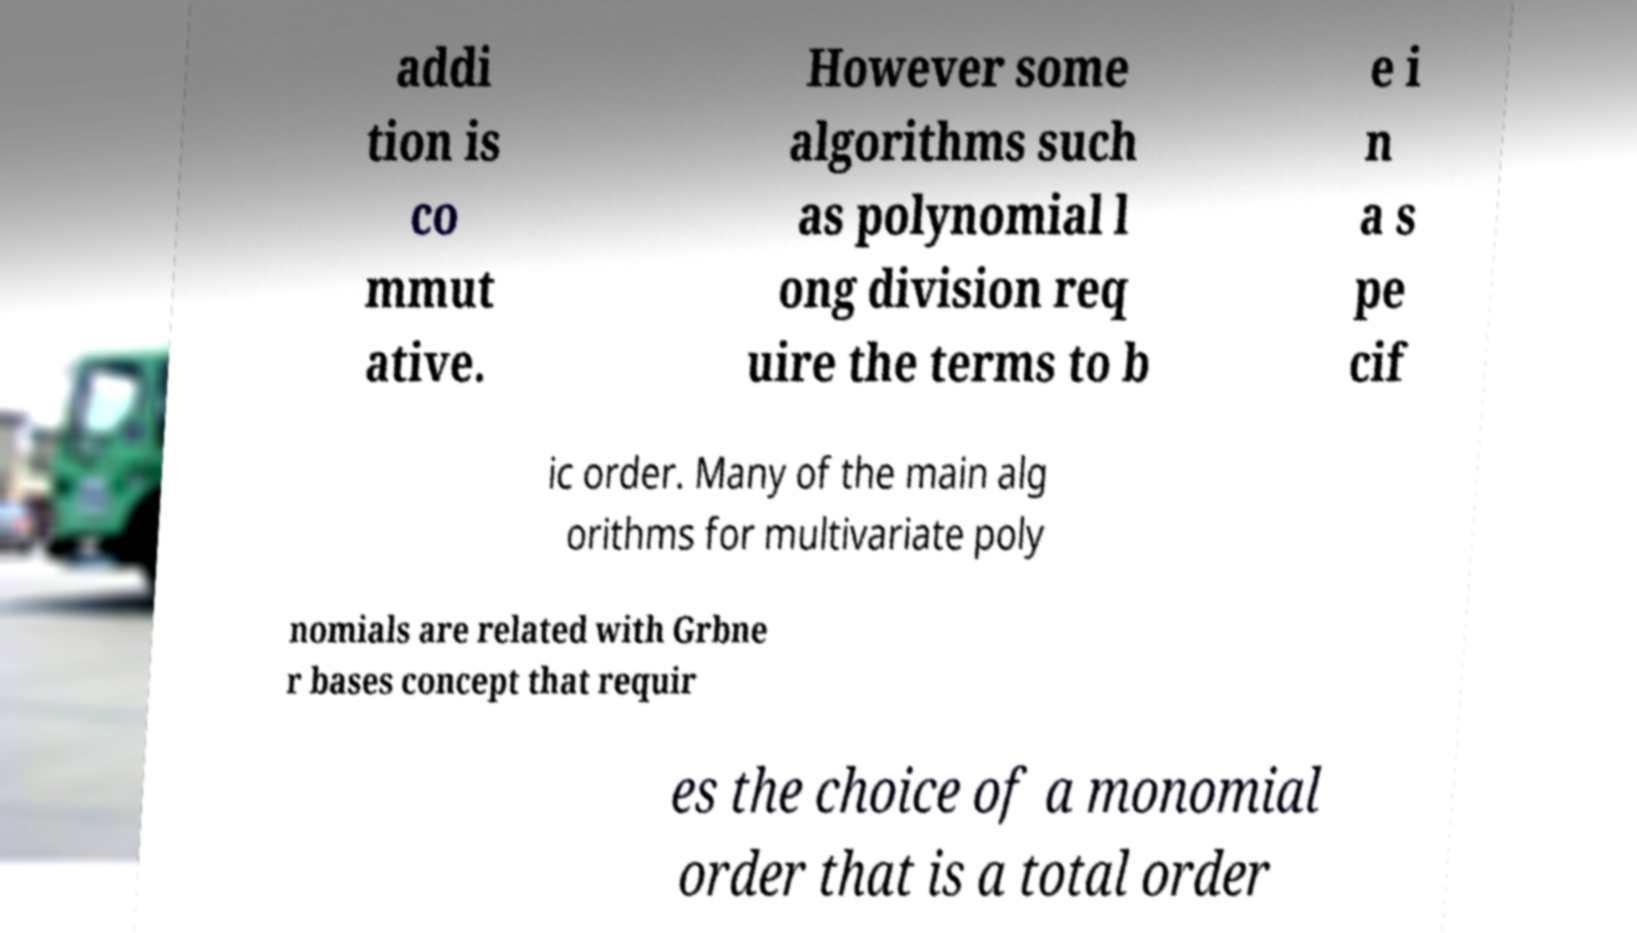Could you assist in decoding the text presented in this image and type it out clearly? addi tion is co mmut ative. However some algorithms such as polynomial l ong division req uire the terms to b e i n a s pe cif ic order. Many of the main alg orithms for multivariate poly nomials are related with Grbne r bases concept that requir es the choice of a monomial order that is a total order 